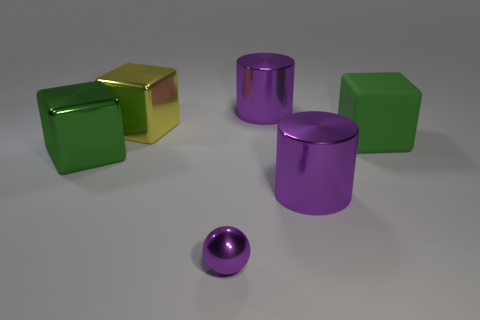Is there any other thing that has the same size as the purple metallic sphere?
Your response must be concise. No. How many other things are the same size as the purple sphere?
Keep it short and to the point. 0. What is the size of the metallic object that is the same color as the large matte thing?
Give a very brief answer. Large. There is a green shiny thing that is to the left of the purple metallic sphere; is it the same shape as the small purple shiny thing?
Your response must be concise. No. How many other things are there of the same shape as the small purple metal thing?
Offer a very short reply. 0. There is a rubber object that is behind the green metal block; what shape is it?
Provide a succinct answer. Cube. Are there any cylinders that have the same material as the yellow thing?
Your response must be concise. Yes. Do the large shiny thing in front of the big green metallic thing and the metallic ball have the same color?
Keep it short and to the point. Yes. The purple metal sphere is what size?
Ensure brevity in your answer.  Small. There is a cylinder on the right side of the purple metal thing that is behind the big green metallic object; are there any green metal blocks to the right of it?
Ensure brevity in your answer.  No. 